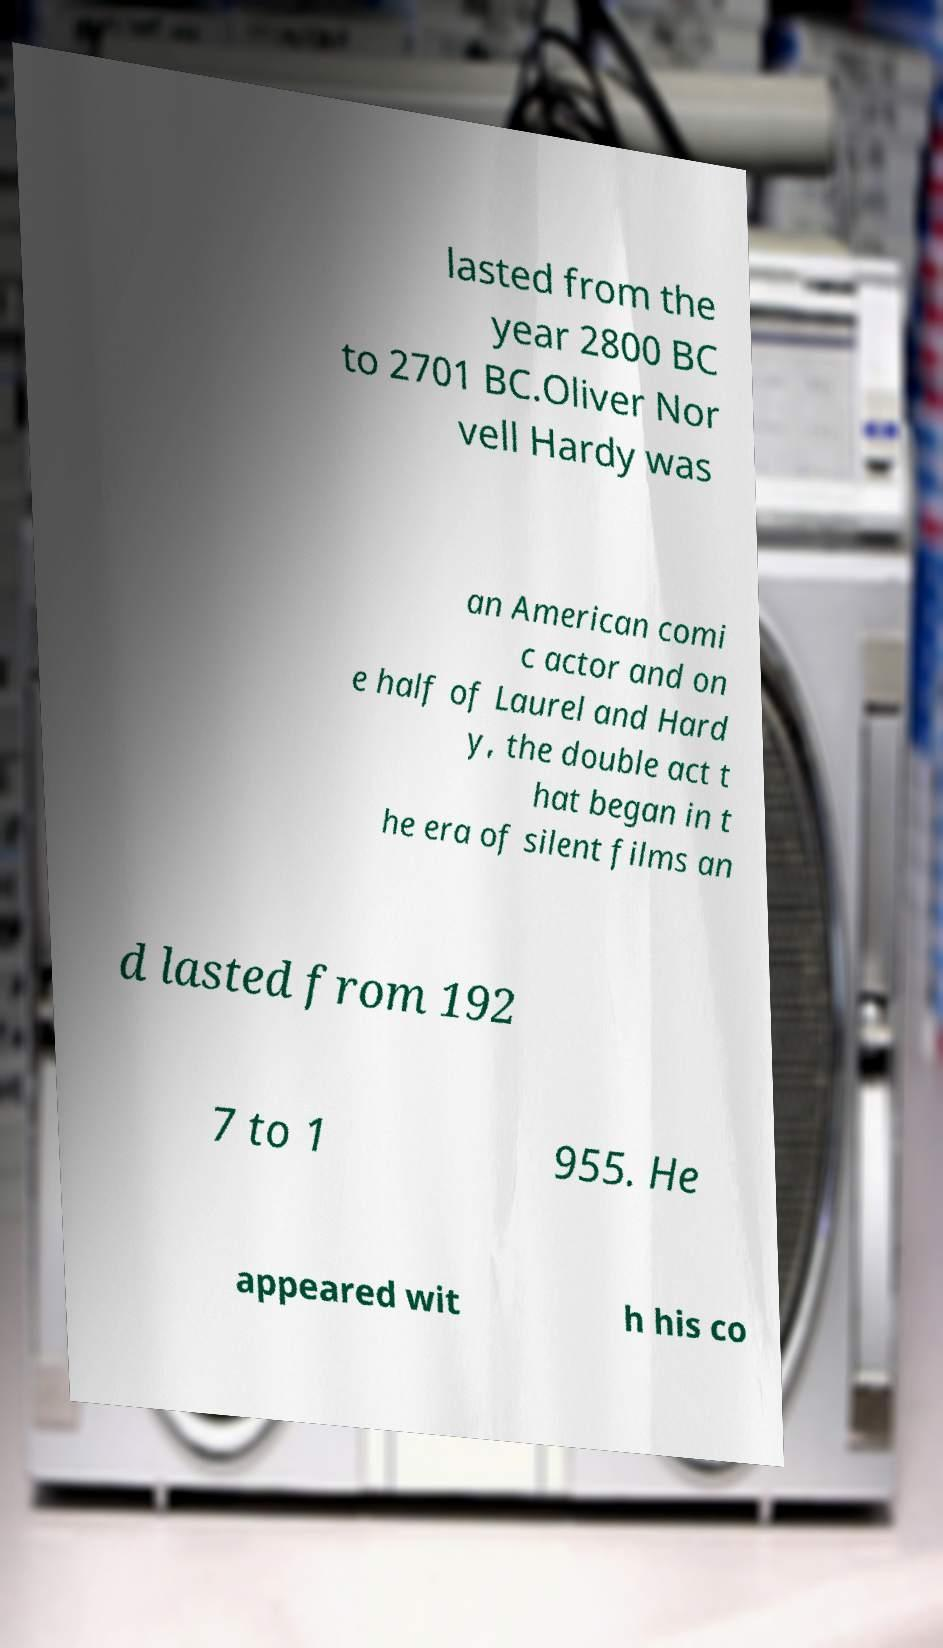Can you accurately transcribe the text from the provided image for me? lasted from the year 2800 BC to 2701 BC.Oliver Nor vell Hardy was an American comi c actor and on e half of Laurel and Hard y, the double act t hat began in t he era of silent films an d lasted from 192 7 to 1 955. He appeared wit h his co 